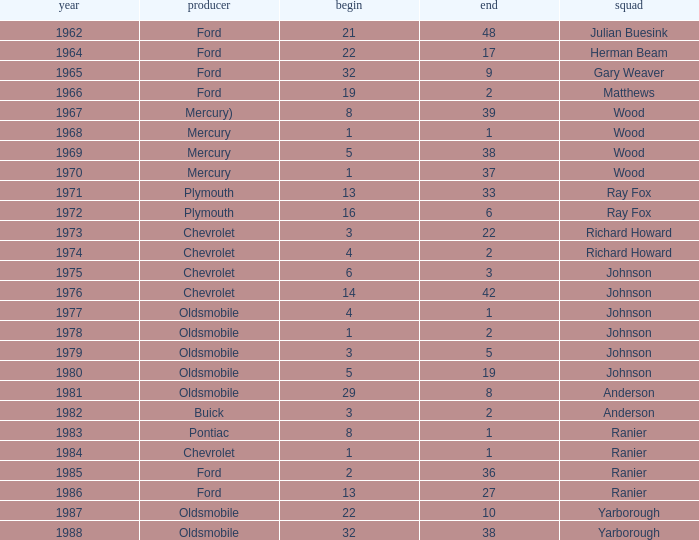What is the smallest finish time for a race after 1972 with a car manufactured by pontiac? 1.0. 